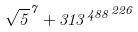<formula> <loc_0><loc_0><loc_500><loc_500>\sqrt { 5 } ^ { 7 } + { 3 1 3 ^ { 4 8 8 } } ^ { 2 2 6 }</formula> 